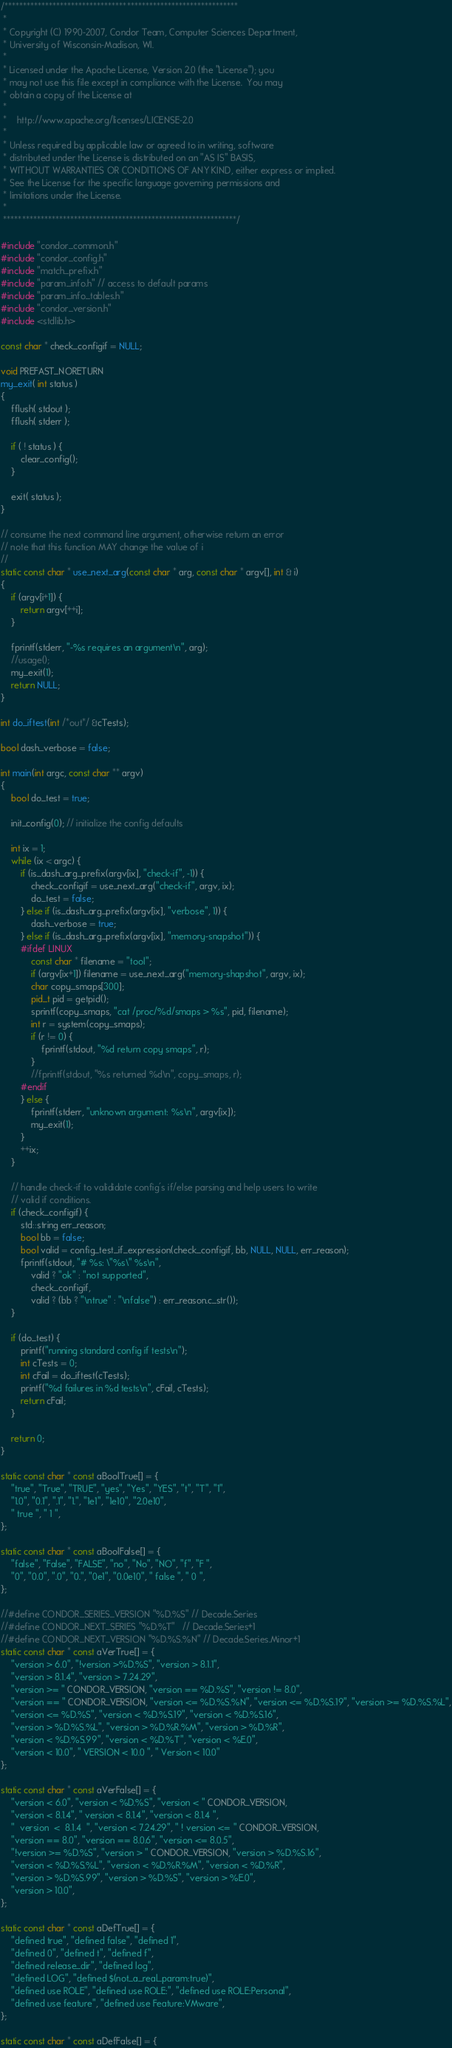Convert code to text. <code><loc_0><loc_0><loc_500><loc_500><_C++_>/***************************************************************
 *
 * Copyright (C) 1990-2007, Condor Team, Computer Sciences Department,
 * University of Wisconsin-Madison, WI.
 * 
 * Licensed under the Apache License, Version 2.0 (the "License"); you
 * may not use this file except in compliance with the License.  You may
 * obtain a copy of the License at
 * 
 *    http://www.apache.org/licenses/LICENSE-2.0
 * 
 * Unless required by applicable law or agreed to in writing, software
 * distributed under the License is distributed on an "AS IS" BASIS,
 * WITHOUT WARRANTIES OR CONDITIONS OF ANY KIND, either express or implied.
 * See the License for the specific language governing permissions and
 * limitations under the License.
 *
 ***************************************************************/

#include "condor_common.h"
#include "condor_config.h"
#include "match_prefix.h"
#include "param_info.h" // access to default params
#include "param_info_tables.h"
#include "condor_version.h"
#include <stdlib.h>

const char * check_configif = NULL;

void PREFAST_NORETURN
my_exit( int status )
{
	fflush( stdout );
	fflush( stderr );

	if ( ! status ) {
		clear_config();
	}

	exit( status );
}

// consume the next command line argument, otherwise return an error
// note that this function MAY change the value of i
//
static const char * use_next_arg(const char * arg, const char * argv[], int & i)
{
	if (argv[i+1]) {
		return argv[++i];
	}

	fprintf(stderr, "-%s requires an argument\n", arg);
	//usage();
	my_exit(1);
	return NULL;
}

int do_iftest(int /*out*/ &cTests);

bool dash_verbose = false;

int main(int argc, const char ** argv)
{
	bool do_test = true;

	init_config(0); // initialize the config defaults

	int ix = 1;
	while (ix < argc) {
		if (is_dash_arg_prefix(argv[ix], "check-if", -1)) {
			check_configif = use_next_arg("check-if", argv, ix);
			do_test = false;
		} else if (is_dash_arg_prefix(argv[ix], "verbose", 1)) {
			dash_verbose = true;
		} else if (is_dash_arg_prefix(argv[ix], "memory-snapshot")) {
		#ifdef LINUX
			const char * filename = "tool";
			if (argv[ix+1]) filename = use_next_arg("memory-shapshot", argv, ix);
			char copy_smaps[300];
			pid_t pid = getpid();
			sprintf(copy_smaps, "cat /proc/%d/smaps > %s", pid, filename);
			int r = system(copy_smaps);
			if (r != 0) {
				fprintf(stdout, "%d return copy smaps", r);
			}
			//fprintf(stdout, "%s returned %d\n", copy_smaps, r);
		#endif
		} else {
			fprintf(stderr, "unknown argument: %s\n", argv[ix]);
			my_exit(1);
		}
		++ix;
	}

	// handle check-if to valididate config's if/else parsing and help users to write
	// valid if conditions.
	if (check_configif) { 
		std::string err_reason;
		bool bb = false;
		bool valid = config_test_if_expression(check_configif, bb, NULL, NULL, err_reason);
		fprintf(stdout, "# %s: \"%s\" %s\n", 
			valid ? "ok" : "not supported", 
			check_configif, 
			valid ? (bb ? "\ntrue" : "\nfalse") : err_reason.c_str());
	}

	if (do_test) {
		printf("running standard config if tests\n");
		int cTests = 0;
		int cFail = do_iftest(cTests);
		printf("%d failures in %d tests\n", cFail, cTests);
		return cFail;
	}

	return 0;
}

static const char * const aBoolTrue[] = {
	"true", "True", "TRUE", "yes", "Yes", "YES", "t", "T", "1",
	"1.0", "0.1", ".1", "1.", "1e1", "1e10", "2.0e10",
	" true ", " 1 ",
};

static const char * const aBoolFalse[] = {
	"false", "False", "FALSE", "no", "No", "NO", "f", "F ",
	"0", "0.0", ".0", "0.", "0e1", "0.0e10", " false ", " 0 ",
};

//#define CONDOR_SERIES_VERSION "%D.%S" // Decade.Series
//#define CONDOR_NEXT_SERIES "%D.%T"   // Decade.Series+1
//#define CONDOR_NEXT_VERSION "%D.%S.%N" // Decade.Series.Minor+1
static const char * const aVerTrue[] = {
	"version > 6.0", "!version >%D.%S", "version > 8.1.1",
	"version > 8.1.4", "version > 7.24.29",
	"version >= " CONDOR_VERSION, "version == %D.%S", "version != 8.0",
	"version == " CONDOR_VERSION, "version <= %D.%S.%N", "version <= %D.%S.19", "version >= %D.%S.%L",
	"version <= %D.%S", "version < %D.%S.19", "version < %D.%S.16",
	"version > %D.%S.%L", "version > %D.%R.%M", "version > %D.%R",
	"version < %D.%S.99", "version < %D.%T", "version < %E.0",
	"version < 10.0", " VERSION < 10.0 ", " Version < 10.0"
};

static const char * const aVerFalse[] = {
	"version < 6.0", "version < %D.%S", "version < " CONDOR_VERSION,
	"version < 8.1.4", " version < 8.1.4", "version < 8.1.4 ",
	"  version  <  8.1.4  ", "version < 7.24.29", " ! version <= " CONDOR_VERSION,
	"version == 8.0", "version == 8.0.6", "version <= 8.0.5",
	"!version >= %D.%S", "version > " CONDOR_VERSION, "version > %D.%S.16",
	"version < %D.%S.%L", "version < %D.%R.%M", "version < %D.%R",
	"version > %D.%S.99", "version > %D.%S", "version > %E.0",
	"version > 10.0",
};

static const char * const aDefTrue[] = {
	"defined true", "defined false", "defined 1",
	"defined 0", "defined t", "defined f",
	"defined release_dir", "defined log",
	"defined LOG", "defined $(not_a_real_param:true)",
	"defined use ROLE", "defined use ROLE:", "defined use ROLE:Personal",
	"defined use feature", "defined use Feature:VMware",
};

static const char * const aDefFalse[] = {</code> 